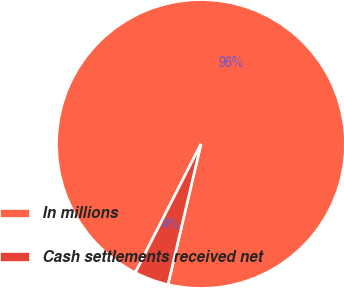Convert chart. <chart><loc_0><loc_0><loc_500><loc_500><pie_chart><fcel>In millions<fcel>Cash settlements received net<nl><fcel>96.16%<fcel>3.84%<nl></chart> 